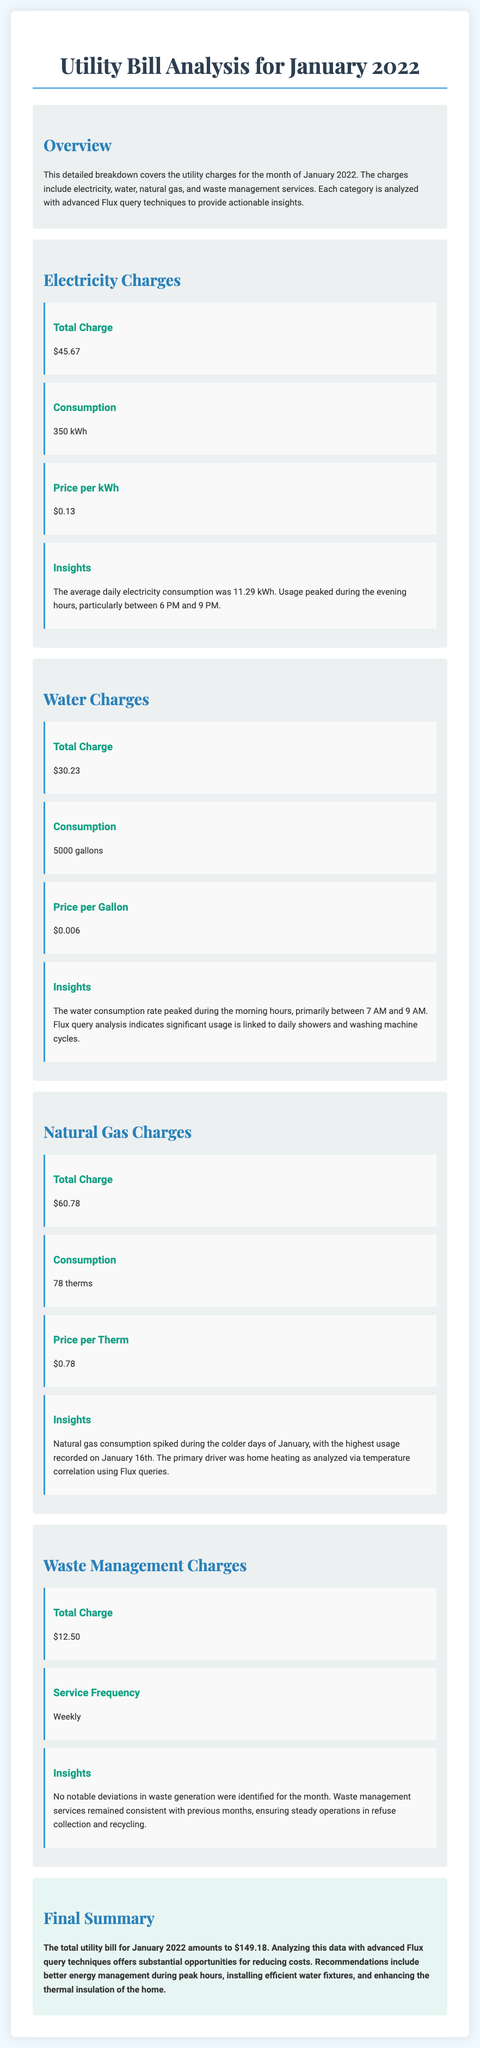What is the total charge for electricity? The total charge for electricity is listed in the document's Electricity Charges section.
Answer: $45.67 How many gallons of water were consumed? The total consumption of water is stated in the Water Charges section of the document.
Answer: 5000 gallons What is the price per therm for natural gas? The price per therm for natural gas can be found in the Natural Gas Charges subsection.
Answer: $0.78 What was the highest natural gas usage day in January? The highest natural gas usage day is mentioned in the insights of the Natural Gas Charges section.
Answer: January 16th What was the total utility bill amount for January 2022? The total utility bill is summarized in the Final Summary section of the document.
Answer: $149.18 During which hours did electricity usage peak? The document indicates the peak electricity usage times in the insights of the Electricity Charges section.
Answer: 6 PM and 9 PM Which service frequency is noted for waste management? The service frequency for waste management is detailed in the Waste Management Charges section.
Answer: Weekly What are the insights for water consumption related to time? The water consumption insights detail the time period of peak usage found in the Water Charges section.
Answer: 7 AM and 9 AM 